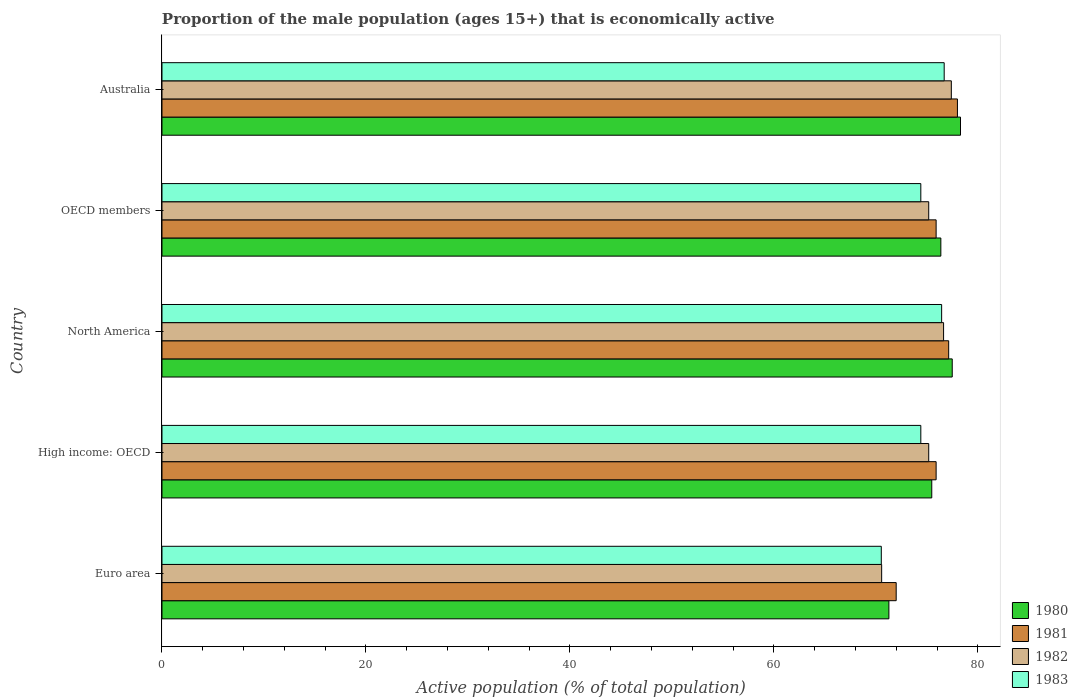How many different coloured bars are there?
Your response must be concise. 4. Are the number of bars on each tick of the Y-axis equal?
Your response must be concise. Yes. How many bars are there on the 3rd tick from the top?
Your answer should be compact. 4. How many bars are there on the 3rd tick from the bottom?
Keep it short and to the point. 4. What is the label of the 2nd group of bars from the top?
Offer a terse response. OECD members. What is the proportion of the male population that is economically active in 1983 in Australia?
Give a very brief answer. 76.7. Across all countries, what is the maximum proportion of the male population that is economically active in 1980?
Provide a succinct answer. 78.3. Across all countries, what is the minimum proportion of the male population that is economically active in 1983?
Your response must be concise. 70.53. In which country was the proportion of the male population that is economically active in 1981 minimum?
Offer a terse response. Euro area. What is the total proportion of the male population that is economically active in 1982 in the graph?
Your response must be concise. 374.97. What is the difference between the proportion of the male population that is economically active in 1982 in Euro area and that in OECD members?
Offer a very short reply. -4.61. What is the difference between the proportion of the male population that is economically active in 1981 in Euro area and the proportion of the male population that is economically active in 1982 in OECD members?
Offer a very short reply. -3.19. What is the average proportion of the male population that is economically active in 1981 per country?
Provide a succinct answer. 75.79. What is the difference between the proportion of the male population that is economically active in 1982 and proportion of the male population that is economically active in 1981 in Australia?
Your answer should be very brief. -0.6. What is the ratio of the proportion of the male population that is economically active in 1981 in Euro area to that in High income: OECD?
Provide a succinct answer. 0.95. Is the proportion of the male population that is economically active in 1982 in North America less than that in OECD members?
Make the answer very short. No. What is the difference between the highest and the second highest proportion of the male population that is economically active in 1981?
Your response must be concise. 0.86. What is the difference between the highest and the lowest proportion of the male population that is economically active in 1983?
Ensure brevity in your answer.  6.17. Is the sum of the proportion of the male population that is economically active in 1982 in Australia and OECD members greater than the maximum proportion of the male population that is economically active in 1980 across all countries?
Keep it short and to the point. Yes. Is it the case that in every country, the sum of the proportion of the male population that is economically active in 1982 and proportion of the male population that is economically active in 1983 is greater than the sum of proportion of the male population that is economically active in 1980 and proportion of the male population that is economically active in 1981?
Make the answer very short. No. What does the 1st bar from the bottom in OECD members represents?
Your answer should be very brief. 1980. How many bars are there?
Offer a very short reply. 20. Are all the bars in the graph horizontal?
Your response must be concise. Yes. What is the difference between two consecutive major ticks on the X-axis?
Your answer should be compact. 20. Does the graph contain grids?
Keep it short and to the point. No. Where does the legend appear in the graph?
Keep it short and to the point. Bottom right. What is the title of the graph?
Keep it short and to the point. Proportion of the male population (ages 15+) that is economically active. What is the label or title of the X-axis?
Keep it short and to the point. Active population (% of total population). What is the label or title of the Y-axis?
Your answer should be very brief. Country. What is the Active population (% of total population) of 1980 in Euro area?
Offer a terse response. 71.28. What is the Active population (% of total population) in 1981 in Euro area?
Ensure brevity in your answer.  71.99. What is the Active population (% of total population) of 1982 in Euro area?
Your response must be concise. 70.57. What is the Active population (% of total population) in 1983 in Euro area?
Ensure brevity in your answer.  70.53. What is the Active population (% of total population) of 1980 in High income: OECD?
Provide a short and direct response. 75.48. What is the Active population (% of total population) in 1981 in High income: OECD?
Make the answer very short. 75.91. What is the Active population (% of total population) in 1982 in High income: OECD?
Your answer should be compact. 75.18. What is the Active population (% of total population) in 1983 in High income: OECD?
Keep it short and to the point. 74.41. What is the Active population (% of total population) in 1980 in North America?
Your response must be concise. 77.49. What is the Active population (% of total population) of 1981 in North America?
Provide a succinct answer. 77.14. What is the Active population (% of total population) in 1982 in North America?
Your answer should be very brief. 76.64. What is the Active population (% of total population) of 1983 in North America?
Provide a succinct answer. 76.45. What is the Active population (% of total population) in 1980 in OECD members?
Make the answer very short. 76.37. What is the Active population (% of total population) of 1981 in OECD members?
Offer a terse response. 75.91. What is the Active population (% of total population) in 1982 in OECD members?
Provide a short and direct response. 75.18. What is the Active population (% of total population) of 1983 in OECD members?
Ensure brevity in your answer.  74.41. What is the Active population (% of total population) in 1980 in Australia?
Provide a succinct answer. 78.3. What is the Active population (% of total population) in 1982 in Australia?
Your response must be concise. 77.4. What is the Active population (% of total population) in 1983 in Australia?
Provide a short and direct response. 76.7. Across all countries, what is the maximum Active population (% of total population) of 1980?
Make the answer very short. 78.3. Across all countries, what is the maximum Active population (% of total population) of 1982?
Offer a very short reply. 77.4. Across all countries, what is the maximum Active population (% of total population) of 1983?
Your answer should be compact. 76.7. Across all countries, what is the minimum Active population (% of total population) of 1980?
Keep it short and to the point. 71.28. Across all countries, what is the minimum Active population (% of total population) in 1981?
Ensure brevity in your answer.  71.99. Across all countries, what is the minimum Active population (% of total population) of 1982?
Provide a succinct answer. 70.57. Across all countries, what is the minimum Active population (% of total population) in 1983?
Give a very brief answer. 70.53. What is the total Active population (% of total population) in 1980 in the graph?
Your answer should be compact. 378.92. What is the total Active population (% of total population) of 1981 in the graph?
Your answer should be very brief. 378.95. What is the total Active population (% of total population) in 1982 in the graph?
Offer a terse response. 374.97. What is the total Active population (% of total population) of 1983 in the graph?
Provide a succinct answer. 372.5. What is the difference between the Active population (% of total population) of 1980 in Euro area and that in High income: OECD?
Give a very brief answer. -4.2. What is the difference between the Active population (% of total population) in 1981 in Euro area and that in High income: OECD?
Keep it short and to the point. -3.92. What is the difference between the Active population (% of total population) of 1982 in Euro area and that in High income: OECD?
Ensure brevity in your answer.  -4.61. What is the difference between the Active population (% of total population) of 1983 in Euro area and that in High income: OECD?
Your response must be concise. -3.87. What is the difference between the Active population (% of total population) of 1980 in Euro area and that in North America?
Keep it short and to the point. -6.21. What is the difference between the Active population (% of total population) in 1981 in Euro area and that in North America?
Keep it short and to the point. -5.15. What is the difference between the Active population (% of total population) in 1982 in Euro area and that in North America?
Your answer should be very brief. -6.07. What is the difference between the Active population (% of total population) in 1983 in Euro area and that in North America?
Your answer should be very brief. -5.92. What is the difference between the Active population (% of total population) of 1980 in Euro area and that in OECD members?
Your answer should be compact. -5.09. What is the difference between the Active population (% of total population) of 1981 in Euro area and that in OECD members?
Keep it short and to the point. -3.92. What is the difference between the Active population (% of total population) of 1982 in Euro area and that in OECD members?
Provide a short and direct response. -4.61. What is the difference between the Active population (% of total population) of 1983 in Euro area and that in OECD members?
Provide a succinct answer. -3.87. What is the difference between the Active population (% of total population) in 1980 in Euro area and that in Australia?
Your response must be concise. -7.02. What is the difference between the Active population (% of total population) in 1981 in Euro area and that in Australia?
Give a very brief answer. -6.01. What is the difference between the Active population (% of total population) in 1982 in Euro area and that in Australia?
Make the answer very short. -6.83. What is the difference between the Active population (% of total population) of 1983 in Euro area and that in Australia?
Provide a succinct answer. -6.17. What is the difference between the Active population (% of total population) of 1980 in High income: OECD and that in North America?
Keep it short and to the point. -2.01. What is the difference between the Active population (% of total population) of 1981 in High income: OECD and that in North America?
Keep it short and to the point. -1.23. What is the difference between the Active population (% of total population) in 1982 in High income: OECD and that in North America?
Make the answer very short. -1.46. What is the difference between the Active population (% of total population) in 1983 in High income: OECD and that in North America?
Make the answer very short. -2.04. What is the difference between the Active population (% of total population) of 1980 in High income: OECD and that in OECD members?
Your answer should be compact. -0.89. What is the difference between the Active population (% of total population) in 1981 in High income: OECD and that in OECD members?
Offer a very short reply. 0. What is the difference between the Active population (% of total population) in 1983 in High income: OECD and that in OECD members?
Ensure brevity in your answer.  0. What is the difference between the Active population (% of total population) in 1980 in High income: OECD and that in Australia?
Offer a very short reply. -2.82. What is the difference between the Active population (% of total population) of 1981 in High income: OECD and that in Australia?
Your answer should be compact. -2.09. What is the difference between the Active population (% of total population) in 1982 in High income: OECD and that in Australia?
Your answer should be compact. -2.22. What is the difference between the Active population (% of total population) of 1983 in High income: OECD and that in Australia?
Offer a terse response. -2.29. What is the difference between the Active population (% of total population) of 1980 in North America and that in OECD members?
Offer a terse response. 1.12. What is the difference between the Active population (% of total population) of 1981 in North America and that in OECD members?
Offer a very short reply. 1.23. What is the difference between the Active population (% of total population) in 1982 in North America and that in OECD members?
Give a very brief answer. 1.46. What is the difference between the Active population (% of total population) in 1983 in North America and that in OECD members?
Make the answer very short. 2.04. What is the difference between the Active population (% of total population) of 1980 in North America and that in Australia?
Provide a short and direct response. -0.81. What is the difference between the Active population (% of total population) in 1981 in North America and that in Australia?
Offer a very short reply. -0.86. What is the difference between the Active population (% of total population) in 1982 in North America and that in Australia?
Your response must be concise. -0.76. What is the difference between the Active population (% of total population) in 1983 in North America and that in Australia?
Give a very brief answer. -0.25. What is the difference between the Active population (% of total population) in 1980 in OECD members and that in Australia?
Keep it short and to the point. -1.93. What is the difference between the Active population (% of total population) of 1981 in OECD members and that in Australia?
Ensure brevity in your answer.  -2.09. What is the difference between the Active population (% of total population) of 1982 in OECD members and that in Australia?
Ensure brevity in your answer.  -2.22. What is the difference between the Active population (% of total population) of 1983 in OECD members and that in Australia?
Your answer should be compact. -2.29. What is the difference between the Active population (% of total population) of 1980 in Euro area and the Active population (% of total population) of 1981 in High income: OECD?
Give a very brief answer. -4.63. What is the difference between the Active population (% of total population) of 1980 in Euro area and the Active population (% of total population) of 1982 in High income: OECD?
Make the answer very short. -3.9. What is the difference between the Active population (% of total population) of 1980 in Euro area and the Active population (% of total population) of 1983 in High income: OECD?
Your response must be concise. -3.13. What is the difference between the Active population (% of total population) of 1981 in Euro area and the Active population (% of total population) of 1982 in High income: OECD?
Your answer should be compact. -3.19. What is the difference between the Active population (% of total population) of 1981 in Euro area and the Active population (% of total population) of 1983 in High income: OECD?
Provide a succinct answer. -2.41. What is the difference between the Active population (% of total population) of 1982 in Euro area and the Active population (% of total population) of 1983 in High income: OECD?
Make the answer very short. -3.84. What is the difference between the Active population (% of total population) in 1980 in Euro area and the Active population (% of total population) in 1981 in North America?
Provide a succinct answer. -5.86. What is the difference between the Active population (% of total population) in 1980 in Euro area and the Active population (% of total population) in 1982 in North America?
Make the answer very short. -5.36. What is the difference between the Active population (% of total population) in 1980 in Euro area and the Active population (% of total population) in 1983 in North America?
Offer a very short reply. -5.17. What is the difference between the Active population (% of total population) in 1981 in Euro area and the Active population (% of total population) in 1982 in North America?
Your response must be concise. -4.65. What is the difference between the Active population (% of total population) in 1981 in Euro area and the Active population (% of total population) in 1983 in North America?
Keep it short and to the point. -4.46. What is the difference between the Active population (% of total population) of 1982 in Euro area and the Active population (% of total population) of 1983 in North America?
Give a very brief answer. -5.88. What is the difference between the Active population (% of total population) of 1980 in Euro area and the Active population (% of total population) of 1981 in OECD members?
Your answer should be very brief. -4.63. What is the difference between the Active population (% of total population) of 1980 in Euro area and the Active population (% of total population) of 1982 in OECD members?
Your answer should be compact. -3.9. What is the difference between the Active population (% of total population) of 1980 in Euro area and the Active population (% of total population) of 1983 in OECD members?
Your response must be concise. -3.13. What is the difference between the Active population (% of total population) in 1981 in Euro area and the Active population (% of total population) in 1982 in OECD members?
Keep it short and to the point. -3.19. What is the difference between the Active population (% of total population) of 1981 in Euro area and the Active population (% of total population) of 1983 in OECD members?
Your answer should be compact. -2.41. What is the difference between the Active population (% of total population) in 1982 in Euro area and the Active population (% of total population) in 1983 in OECD members?
Your answer should be compact. -3.84. What is the difference between the Active population (% of total population) in 1980 in Euro area and the Active population (% of total population) in 1981 in Australia?
Make the answer very short. -6.72. What is the difference between the Active population (% of total population) of 1980 in Euro area and the Active population (% of total population) of 1982 in Australia?
Provide a short and direct response. -6.12. What is the difference between the Active population (% of total population) in 1980 in Euro area and the Active population (% of total population) in 1983 in Australia?
Make the answer very short. -5.42. What is the difference between the Active population (% of total population) in 1981 in Euro area and the Active population (% of total population) in 1982 in Australia?
Give a very brief answer. -5.41. What is the difference between the Active population (% of total population) of 1981 in Euro area and the Active population (% of total population) of 1983 in Australia?
Your response must be concise. -4.71. What is the difference between the Active population (% of total population) of 1982 in Euro area and the Active population (% of total population) of 1983 in Australia?
Ensure brevity in your answer.  -6.13. What is the difference between the Active population (% of total population) in 1980 in High income: OECD and the Active population (% of total population) in 1981 in North America?
Your answer should be compact. -1.66. What is the difference between the Active population (% of total population) in 1980 in High income: OECD and the Active population (% of total population) in 1982 in North America?
Offer a very short reply. -1.16. What is the difference between the Active population (% of total population) in 1980 in High income: OECD and the Active population (% of total population) in 1983 in North America?
Provide a succinct answer. -0.97. What is the difference between the Active population (% of total population) of 1981 in High income: OECD and the Active population (% of total population) of 1982 in North America?
Make the answer very short. -0.73. What is the difference between the Active population (% of total population) of 1981 in High income: OECD and the Active population (% of total population) of 1983 in North America?
Offer a very short reply. -0.54. What is the difference between the Active population (% of total population) of 1982 in High income: OECD and the Active population (% of total population) of 1983 in North America?
Give a very brief answer. -1.27. What is the difference between the Active population (% of total population) in 1980 in High income: OECD and the Active population (% of total population) in 1981 in OECD members?
Offer a very short reply. -0.43. What is the difference between the Active population (% of total population) in 1980 in High income: OECD and the Active population (% of total population) in 1982 in OECD members?
Offer a very short reply. 0.3. What is the difference between the Active population (% of total population) in 1980 in High income: OECD and the Active population (% of total population) in 1983 in OECD members?
Provide a short and direct response. 1.07. What is the difference between the Active population (% of total population) in 1981 in High income: OECD and the Active population (% of total population) in 1982 in OECD members?
Provide a short and direct response. 0.73. What is the difference between the Active population (% of total population) of 1981 in High income: OECD and the Active population (% of total population) of 1983 in OECD members?
Make the answer very short. 1.5. What is the difference between the Active population (% of total population) of 1982 in High income: OECD and the Active population (% of total population) of 1983 in OECD members?
Provide a succinct answer. 0.77. What is the difference between the Active population (% of total population) of 1980 in High income: OECD and the Active population (% of total population) of 1981 in Australia?
Keep it short and to the point. -2.52. What is the difference between the Active population (% of total population) of 1980 in High income: OECD and the Active population (% of total population) of 1982 in Australia?
Make the answer very short. -1.92. What is the difference between the Active population (% of total population) in 1980 in High income: OECD and the Active population (% of total population) in 1983 in Australia?
Your answer should be compact. -1.22. What is the difference between the Active population (% of total population) of 1981 in High income: OECD and the Active population (% of total population) of 1982 in Australia?
Make the answer very short. -1.49. What is the difference between the Active population (% of total population) in 1981 in High income: OECD and the Active population (% of total population) in 1983 in Australia?
Your answer should be very brief. -0.79. What is the difference between the Active population (% of total population) in 1982 in High income: OECD and the Active population (% of total population) in 1983 in Australia?
Provide a succinct answer. -1.52. What is the difference between the Active population (% of total population) in 1980 in North America and the Active population (% of total population) in 1981 in OECD members?
Your answer should be compact. 1.58. What is the difference between the Active population (% of total population) in 1980 in North America and the Active population (% of total population) in 1982 in OECD members?
Provide a short and direct response. 2.31. What is the difference between the Active population (% of total population) in 1980 in North America and the Active population (% of total population) in 1983 in OECD members?
Make the answer very short. 3.08. What is the difference between the Active population (% of total population) in 1981 in North America and the Active population (% of total population) in 1982 in OECD members?
Provide a short and direct response. 1.96. What is the difference between the Active population (% of total population) in 1981 in North America and the Active population (% of total population) in 1983 in OECD members?
Your response must be concise. 2.73. What is the difference between the Active population (% of total population) of 1982 in North America and the Active population (% of total population) of 1983 in OECD members?
Offer a terse response. 2.23. What is the difference between the Active population (% of total population) in 1980 in North America and the Active population (% of total population) in 1981 in Australia?
Keep it short and to the point. -0.51. What is the difference between the Active population (% of total population) in 1980 in North America and the Active population (% of total population) in 1982 in Australia?
Ensure brevity in your answer.  0.09. What is the difference between the Active population (% of total population) in 1980 in North America and the Active population (% of total population) in 1983 in Australia?
Keep it short and to the point. 0.79. What is the difference between the Active population (% of total population) of 1981 in North America and the Active population (% of total population) of 1982 in Australia?
Provide a succinct answer. -0.26. What is the difference between the Active population (% of total population) in 1981 in North America and the Active population (% of total population) in 1983 in Australia?
Provide a succinct answer. 0.44. What is the difference between the Active population (% of total population) of 1982 in North America and the Active population (% of total population) of 1983 in Australia?
Provide a short and direct response. -0.06. What is the difference between the Active population (% of total population) in 1980 in OECD members and the Active population (% of total population) in 1981 in Australia?
Ensure brevity in your answer.  -1.63. What is the difference between the Active population (% of total population) in 1980 in OECD members and the Active population (% of total population) in 1982 in Australia?
Offer a very short reply. -1.03. What is the difference between the Active population (% of total population) of 1980 in OECD members and the Active population (% of total population) of 1983 in Australia?
Your answer should be compact. -0.33. What is the difference between the Active population (% of total population) of 1981 in OECD members and the Active population (% of total population) of 1982 in Australia?
Your answer should be compact. -1.49. What is the difference between the Active population (% of total population) of 1981 in OECD members and the Active population (% of total population) of 1983 in Australia?
Your response must be concise. -0.79. What is the difference between the Active population (% of total population) in 1982 in OECD members and the Active population (% of total population) in 1983 in Australia?
Provide a short and direct response. -1.52. What is the average Active population (% of total population) of 1980 per country?
Ensure brevity in your answer.  75.78. What is the average Active population (% of total population) in 1981 per country?
Offer a terse response. 75.79. What is the average Active population (% of total population) of 1982 per country?
Give a very brief answer. 74.99. What is the average Active population (% of total population) in 1983 per country?
Offer a terse response. 74.5. What is the difference between the Active population (% of total population) in 1980 and Active population (% of total population) in 1981 in Euro area?
Provide a succinct answer. -0.72. What is the difference between the Active population (% of total population) in 1980 and Active population (% of total population) in 1982 in Euro area?
Your response must be concise. 0.71. What is the difference between the Active population (% of total population) of 1980 and Active population (% of total population) of 1983 in Euro area?
Your answer should be compact. 0.74. What is the difference between the Active population (% of total population) of 1981 and Active population (% of total population) of 1982 in Euro area?
Ensure brevity in your answer.  1.43. What is the difference between the Active population (% of total population) of 1981 and Active population (% of total population) of 1983 in Euro area?
Provide a succinct answer. 1.46. What is the difference between the Active population (% of total population) in 1982 and Active population (% of total population) in 1983 in Euro area?
Your response must be concise. 0.03. What is the difference between the Active population (% of total population) in 1980 and Active population (% of total population) in 1981 in High income: OECD?
Your answer should be compact. -0.43. What is the difference between the Active population (% of total population) in 1980 and Active population (% of total population) in 1982 in High income: OECD?
Keep it short and to the point. 0.3. What is the difference between the Active population (% of total population) in 1980 and Active population (% of total population) in 1983 in High income: OECD?
Ensure brevity in your answer.  1.07. What is the difference between the Active population (% of total population) in 1981 and Active population (% of total population) in 1982 in High income: OECD?
Your answer should be very brief. 0.73. What is the difference between the Active population (% of total population) of 1981 and Active population (% of total population) of 1983 in High income: OECD?
Ensure brevity in your answer.  1.5. What is the difference between the Active population (% of total population) of 1982 and Active population (% of total population) of 1983 in High income: OECD?
Provide a succinct answer. 0.77. What is the difference between the Active population (% of total population) of 1980 and Active population (% of total population) of 1981 in North America?
Your answer should be very brief. 0.35. What is the difference between the Active population (% of total population) of 1980 and Active population (% of total population) of 1982 in North America?
Offer a terse response. 0.85. What is the difference between the Active population (% of total population) of 1980 and Active population (% of total population) of 1983 in North America?
Offer a very short reply. 1.04. What is the difference between the Active population (% of total population) in 1981 and Active population (% of total population) in 1982 in North America?
Offer a very short reply. 0.5. What is the difference between the Active population (% of total population) of 1981 and Active population (% of total population) of 1983 in North America?
Give a very brief answer. 0.69. What is the difference between the Active population (% of total population) in 1982 and Active population (% of total population) in 1983 in North America?
Provide a short and direct response. 0.19. What is the difference between the Active population (% of total population) in 1980 and Active population (% of total population) in 1981 in OECD members?
Offer a terse response. 0.46. What is the difference between the Active population (% of total population) of 1980 and Active population (% of total population) of 1982 in OECD members?
Your response must be concise. 1.19. What is the difference between the Active population (% of total population) in 1980 and Active population (% of total population) in 1983 in OECD members?
Ensure brevity in your answer.  1.96. What is the difference between the Active population (% of total population) of 1981 and Active population (% of total population) of 1982 in OECD members?
Ensure brevity in your answer.  0.73. What is the difference between the Active population (% of total population) in 1981 and Active population (% of total population) in 1983 in OECD members?
Give a very brief answer. 1.5. What is the difference between the Active population (% of total population) of 1982 and Active population (% of total population) of 1983 in OECD members?
Offer a very short reply. 0.77. What is the difference between the Active population (% of total population) of 1980 and Active population (% of total population) of 1982 in Australia?
Your answer should be compact. 0.9. What is the difference between the Active population (% of total population) of 1980 and Active population (% of total population) of 1983 in Australia?
Keep it short and to the point. 1.6. What is the difference between the Active population (% of total population) in 1981 and Active population (% of total population) in 1983 in Australia?
Your response must be concise. 1.3. What is the ratio of the Active population (% of total population) in 1980 in Euro area to that in High income: OECD?
Your response must be concise. 0.94. What is the ratio of the Active population (% of total population) in 1981 in Euro area to that in High income: OECD?
Provide a succinct answer. 0.95. What is the ratio of the Active population (% of total population) of 1982 in Euro area to that in High income: OECD?
Offer a very short reply. 0.94. What is the ratio of the Active population (% of total population) in 1983 in Euro area to that in High income: OECD?
Your answer should be compact. 0.95. What is the ratio of the Active population (% of total population) of 1980 in Euro area to that in North America?
Keep it short and to the point. 0.92. What is the ratio of the Active population (% of total population) in 1982 in Euro area to that in North America?
Offer a very short reply. 0.92. What is the ratio of the Active population (% of total population) in 1983 in Euro area to that in North America?
Provide a short and direct response. 0.92. What is the ratio of the Active population (% of total population) in 1980 in Euro area to that in OECD members?
Your response must be concise. 0.93. What is the ratio of the Active population (% of total population) in 1981 in Euro area to that in OECD members?
Provide a short and direct response. 0.95. What is the ratio of the Active population (% of total population) in 1982 in Euro area to that in OECD members?
Offer a terse response. 0.94. What is the ratio of the Active population (% of total population) in 1983 in Euro area to that in OECD members?
Ensure brevity in your answer.  0.95. What is the ratio of the Active population (% of total population) in 1980 in Euro area to that in Australia?
Provide a succinct answer. 0.91. What is the ratio of the Active population (% of total population) in 1981 in Euro area to that in Australia?
Make the answer very short. 0.92. What is the ratio of the Active population (% of total population) in 1982 in Euro area to that in Australia?
Give a very brief answer. 0.91. What is the ratio of the Active population (% of total population) in 1983 in Euro area to that in Australia?
Your answer should be very brief. 0.92. What is the ratio of the Active population (% of total population) in 1980 in High income: OECD to that in North America?
Give a very brief answer. 0.97. What is the ratio of the Active population (% of total population) of 1981 in High income: OECD to that in North America?
Offer a very short reply. 0.98. What is the ratio of the Active population (% of total population) in 1982 in High income: OECD to that in North America?
Your answer should be compact. 0.98. What is the ratio of the Active population (% of total population) in 1983 in High income: OECD to that in North America?
Offer a terse response. 0.97. What is the ratio of the Active population (% of total population) of 1980 in High income: OECD to that in OECD members?
Ensure brevity in your answer.  0.99. What is the ratio of the Active population (% of total population) in 1982 in High income: OECD to that in OECD members?
Provide a succinct answer. 1. What is the ratio of the Active population (% of total population) in 1983 in High income: OECD to that in OECD members?
Offer a very short reply. 1. What is the ratio of the Active population (% of total population) in 1981 in High income: OECD to that in Australia?
Provide a short and direct response. 0.97. What is the ratio of the Active population (% of total population) in 1982 in High income: OECD to that in Australia?
Provide a succinct answer. 0.97. What is the ratio of the Active population (% of total population) of 1983 in High income: OECD to that in Australia?
Your response must be concise. 0.97. What is the ratio of the Active population (% of total population) in 1980 in North America to that in OECD members?
Keep it short and to the point. 1.01. What is the ratio of the Active population (% of total population) in 1981 in North America to that in OECD members?
Your answer should be compact. 1.02. What is the ratio of the Active population (% of total population) in 1982 in North America to that in OECD members?
Give a very brief answer. 1.02. What is the ratio of the Active population (% of total population) in 1983 in North America to that in OECD members?
Ensure brevity in your answer.  1.03. What is the ratio of the Active population (% of total population) of 1981 in North America to that in Australia?
Your answer should be compact. 0.99. What is the ratio of the Active population (% of total population) of 1982 in North America to that in Australia?
Keep it short and to the point. 0.99. What is the ratio of the Active population (% of total population) of 1980 in OECD members to that in Australia?
Provide a short and direct response. 0.98. What is the ratio of the Active population (% of total population) of 1981 in OECD members to that in Australia?
Ensure brevity in your answer.  0.97. What is the ratio of the Active population (% of total population) in 1982 in OECD members to that in Australia?
Ensure brevity in your answer.  0.97. What is the ratio of the Active population (% of total population) in 1983 in OECD members to that in Australia?
Your response must be concise. 0.97. What is the difference between the highest and the second highest Active population (% of total population) of 1980?
Your answer should be very brief. 0.81. What is the difference between the highest and the second highest Active population (% of total population) of 1981?
Offer a terse response. 0.86. What is the difference between the highest and the second highest Active population (% of total population) in 1982?
Provide a succinct answer. 0.76. What is the difference between the highest and the second highest Active population (% of total population) of 1983?
Keep it short and to the point. 0.25. What is the difference between the highest and the lowest Active population (% of total population) in 1980?
Provide a succinct answer. 7.02. What is the difference between the highest and the lowest Active population (% of total population) of 1981?
Your response must be concise. 6.01. What is the difference between the highest and the lowest Active population (% of total population) in 1982?
Keep it short and to the point. 6.83. What is the difference between the highest and the lowest Active population (% of total population) in 1983?
Offer a very short reply. 6.17. 